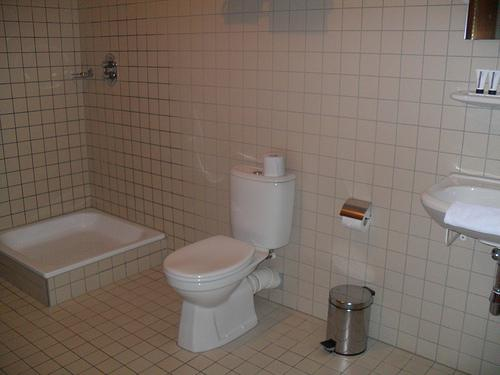Question: what color is the trash can?
Choices:
A. Black.
B. White.
C. Silver.
D. Blue.
Answer with the letter. Answer: C Question: what room is this?
Choices:
A. Bathroom.
B. Dining room.
C. Foyer.
D. Bed room.
Answer with the letter. Answer: A Question: where is the toilet?
Choices:
A. Against the wall.
B. Beside the bath tub.
C. On the front porch.
D. Beside the sink.
Answer with the letter. Answer: A Question: what shape is the shower?
Choices:
A. Oval.
B. Circular.
C. Square.
D. Hexagonal.
Answer with the letter. Answer: C Question: what is the flooring?
Choices:
A. Wood.
B. Stone.
C. Ceramic.
D. Tile.
Answer with the letter. Answer: D 